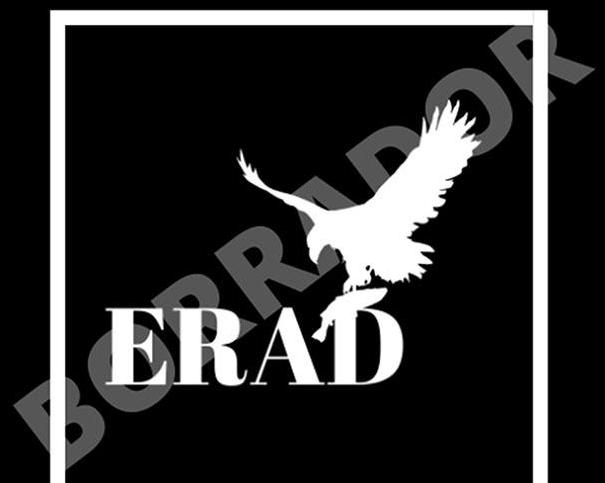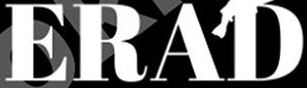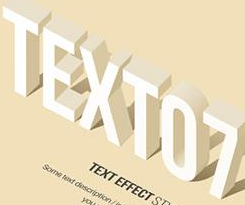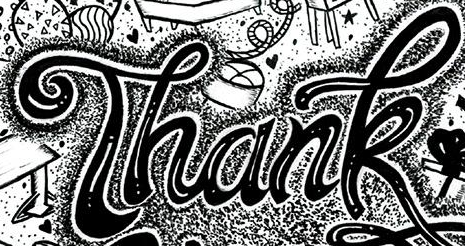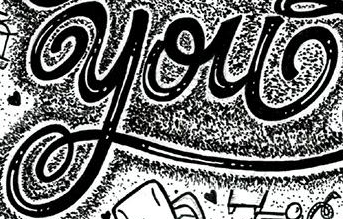Read the text content from these images in order, separated by a semicolon. BORRADOR; ERAD; TEXTO7; Thank; you 